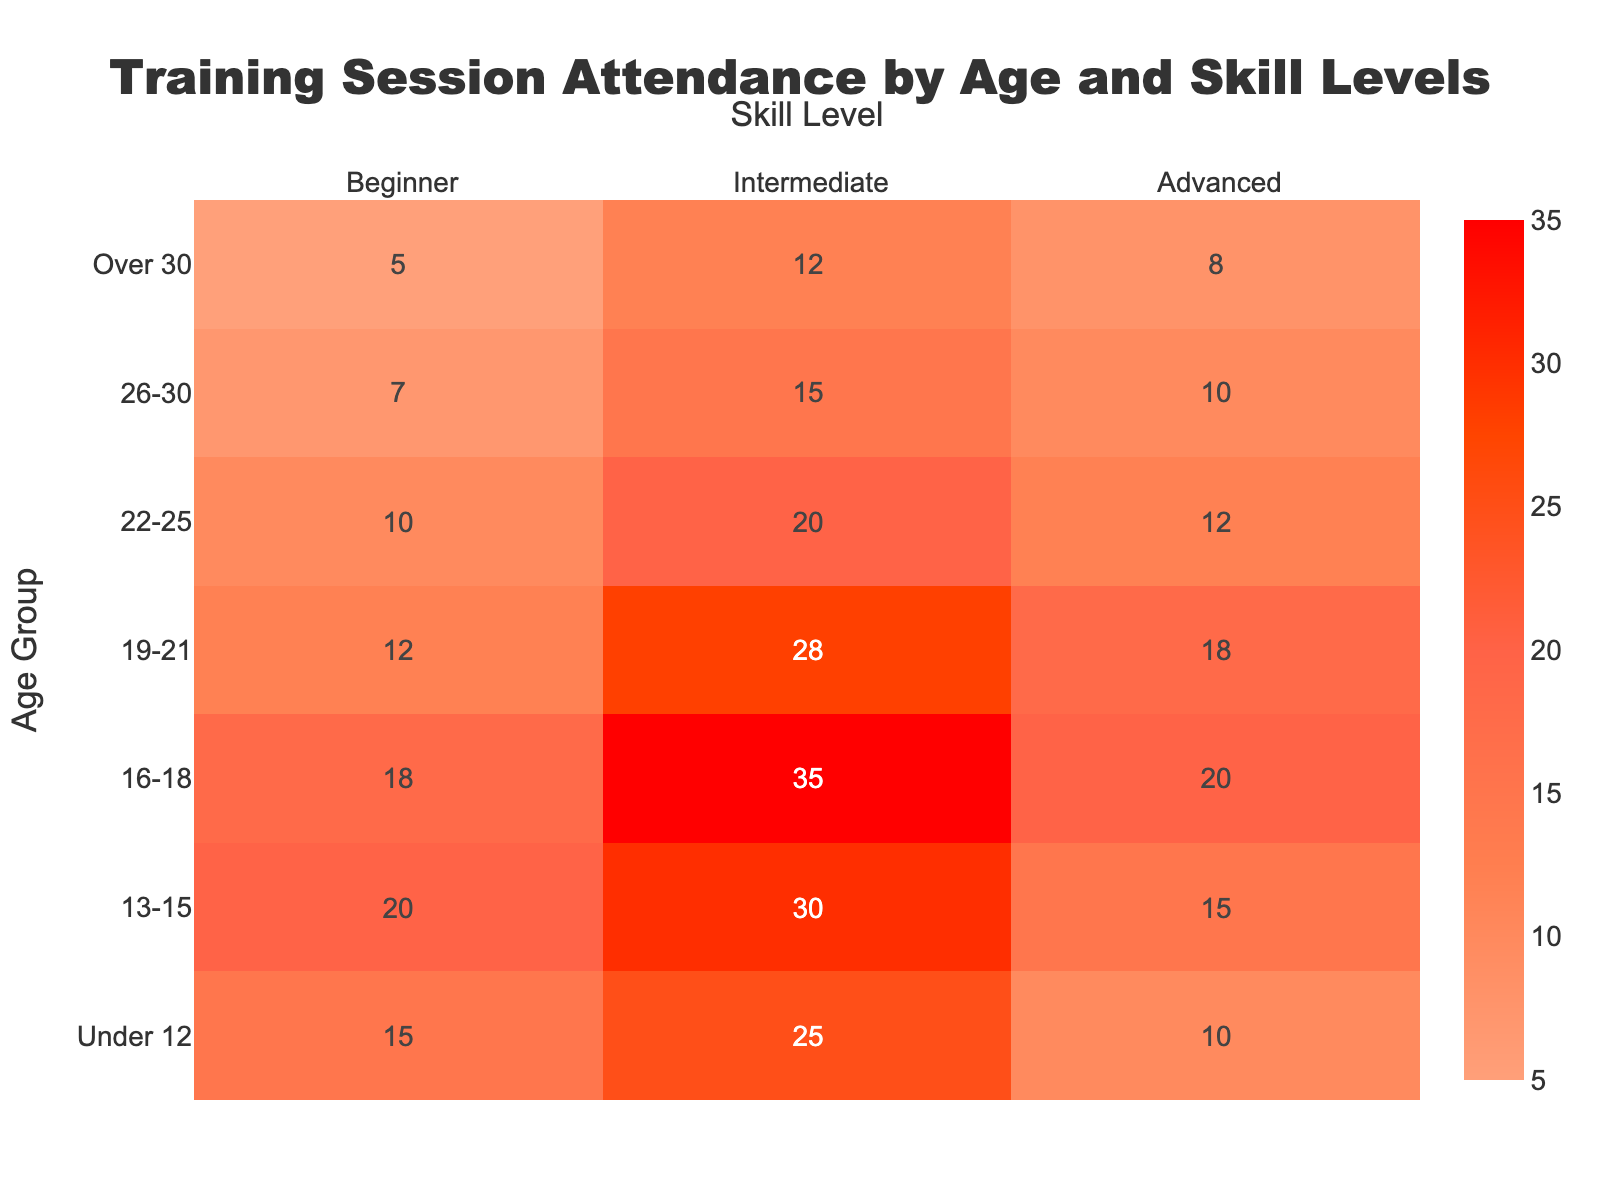what is the overall trend in the attendance for the 'Advanced' skill level across different age groups? The attendance for the 'Advanced' skill level generally increases from younger to older age groups until '16-18', then slightly decreases. By inspecting the heatmap, we see the values increase from 'Under 12' (10) to '16-18' (20), then decrease in '19-21' (18) and remain relatively lower for older groups.
Answer: Increases until 16-18, then decreases which age group has the highest attendance in the 'Intermediate' skill level? By looking at the heatmap, we identify the highest value in the 'Intermediate' column. The age group '16-18' has the highest attendance with a value of 35.
Answer: 16-18 compare the attendance of 'Beginners' in the 'Under 12' age group to the attendance of 'Advanced' in the 'Over 30' age group. Which is higher? From the heatmap, 'Beginner' attendance for 'Under 12' is 15, and 'Advanced' attendance for 'Over 30' is 8. Since 15 is greater than 8, the 'Beginner' attendance in 'Under 12' is higher.
Answer: 'Beginner' in 'Under 12' what is the difference in attendance between 'Intermediate' and 'Beginner' skill levels for the '13-15' age group? For the '13-15' age group, the 'Intermediate' attendance is 30, and 'Beginner' attendance is 20. The difference is calculated as 30 - 20.
Answer: 10 in which age group is the color darkest for the 'Advanced' skill level? The darkest color in the 'Advanced' skill level (signifying highest attendance) is in the '16-18' age group, which has the value of 20.
Answer: 16-18 what is the total attendance for the '26-30' age group across all skill levels? In the '26-30' age group, the attendance values are 7 (Beginner), 15 (Intermediate), and 10 (Advanced). The total is calculated as 7 + 15 + 10.
Answer: 32 which skill level has the most consistent attendance across all age groups and why? By analyzing the heatmap values, 'Intermediate' appears most consistent because its numbers change less drastically compared to 'Beginner' and 'Advanced'. Values range between 12 and 35.
Answer: Intermediate what is the average attendance for 'Advanced' across all age groups? The 'Advanced' attendance values are 10, 15, 20, 18, 12, 10, 8. Summing these values gives 93. The average is 93 divided by 7 (number of age groups).
Answer: 13.29 